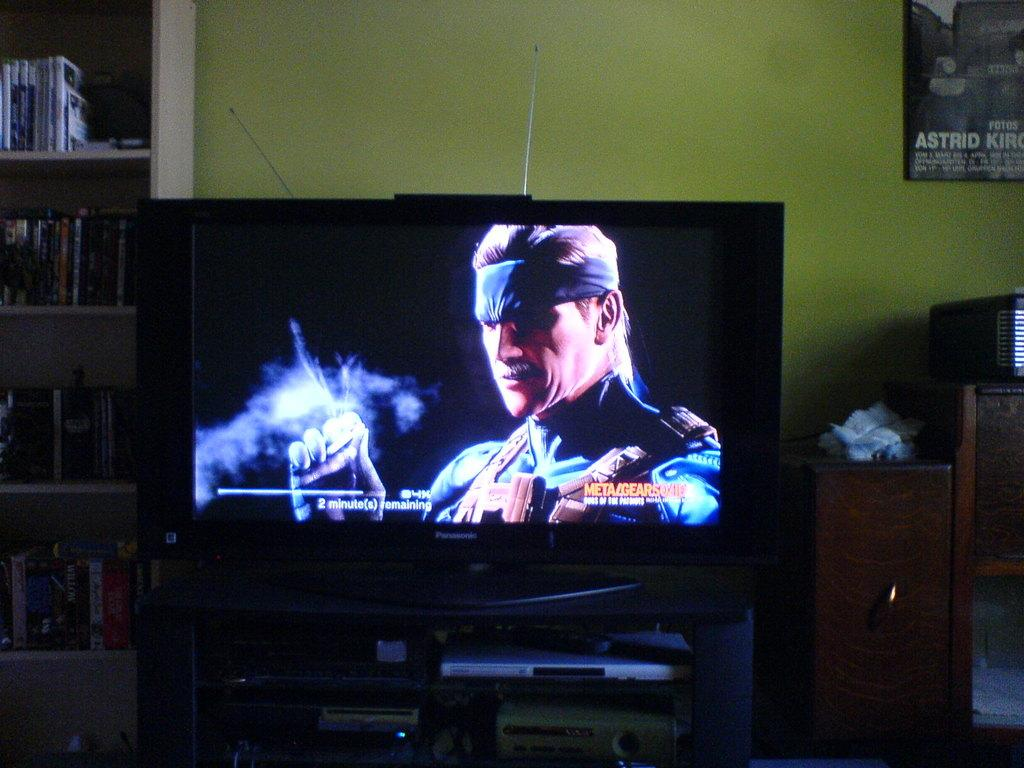<image>
Provide a brief description of the given image. an ad on the television for metal gear solid 